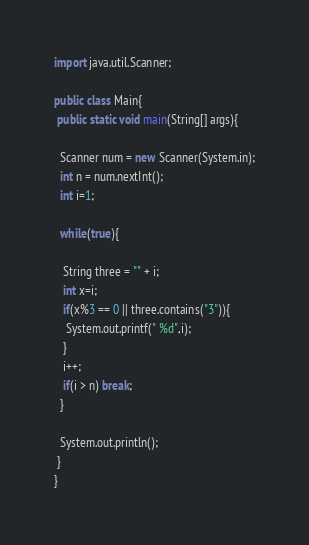<code> <loc_0><loc_0><loc_500><loc_500><_Java_>import java.util.Scanner;

public class Main{
 public static void main(String[] args){
  
  Scanner num = new Scanner(System.in);
  int n = num.nextInt();
  int i=1;
  
  while(true){
   
   String three = "" + i;
   int x=i;
   if(x%3 == 0 || three.contains("3")){
    System.out.printf(" %d",i);
   }
   i++;
   if(i > n) break;
  }
  
  System.out.println();
 }
}</code> 